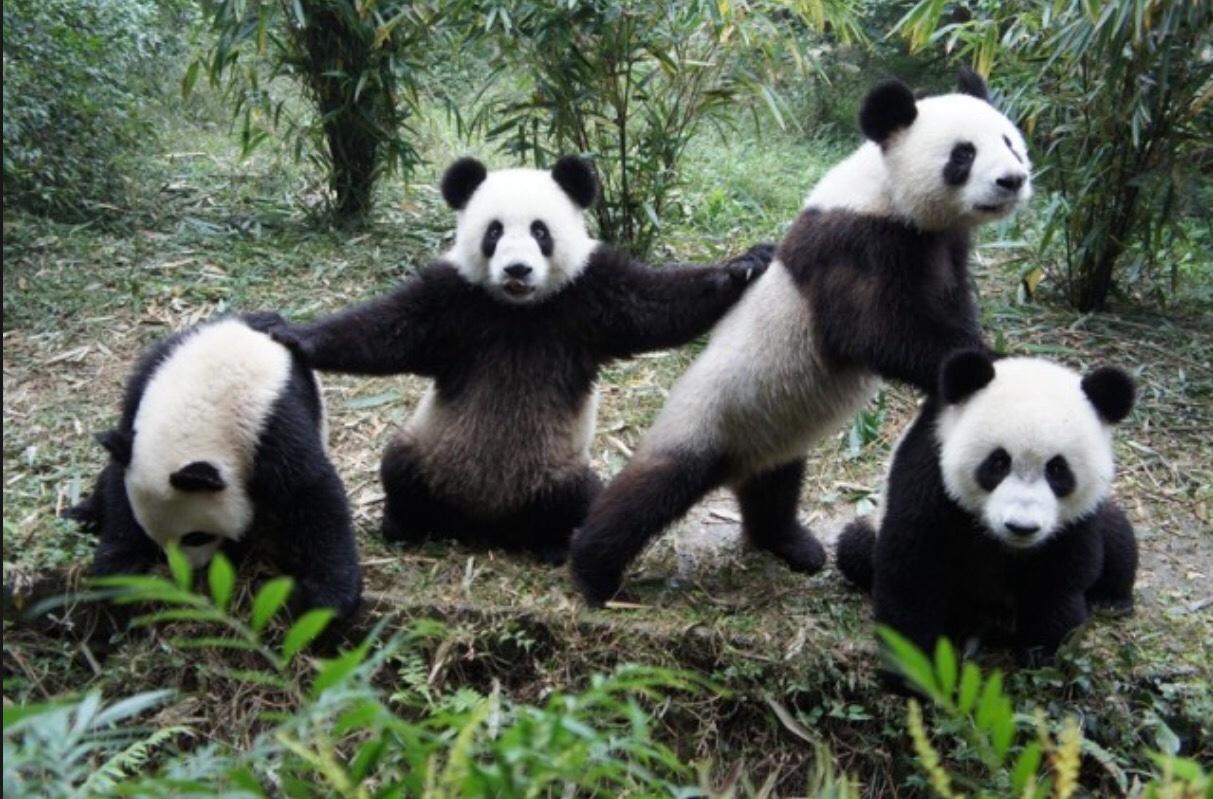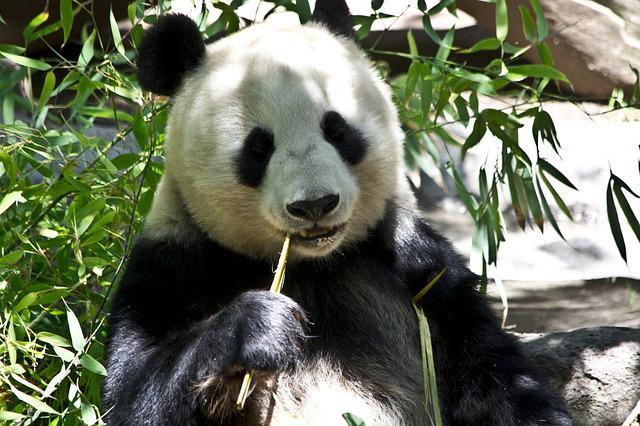The first image is the image on the left, the second image is the image on the right. Considering the images on both sides, is "The right image shows one panda, which is posed with open mouth to munch on a green stem." valid? Answer yes or no. Yes. The first image is the image on the left, the second image is the image on the right. Considering the images on both sides, is "An image contains at lest four pandas." valid? Answer yes or no. Yes. 